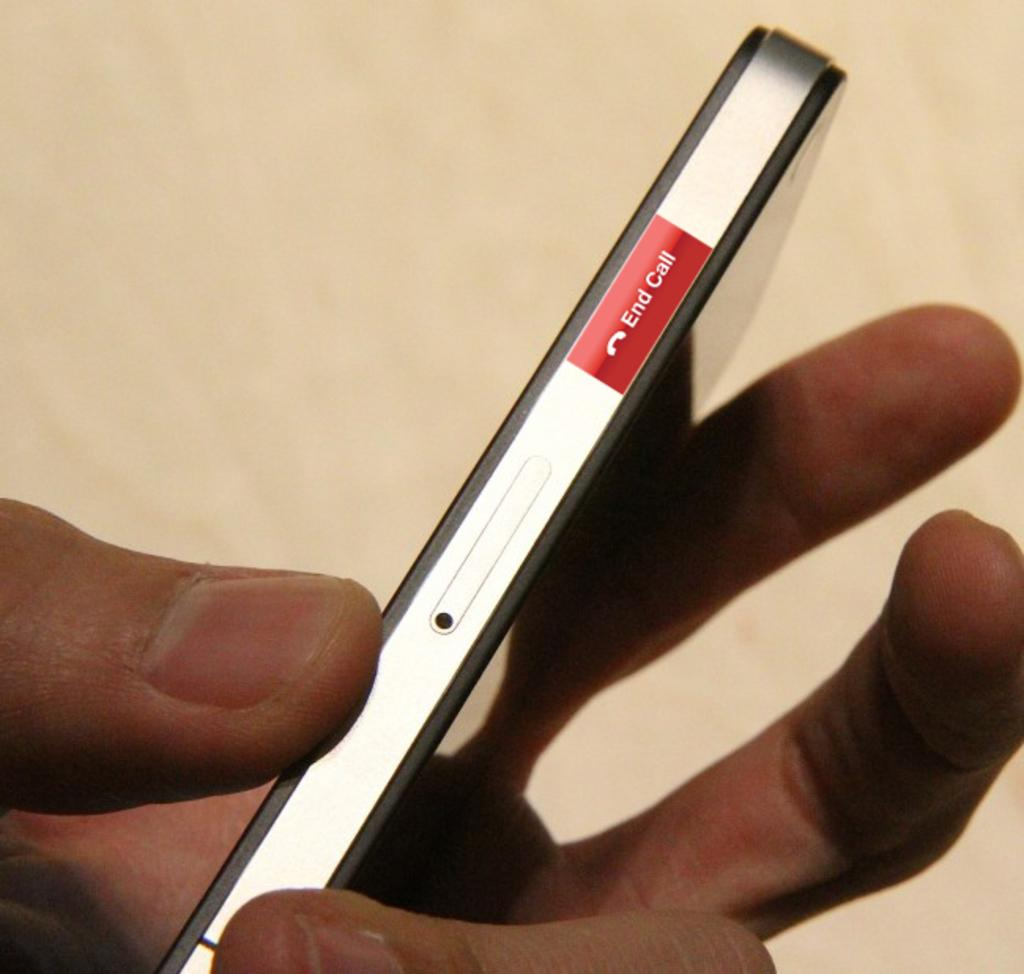<image>
Describe the image concisely. Person holding a phone that has a red bar saying End Call. 